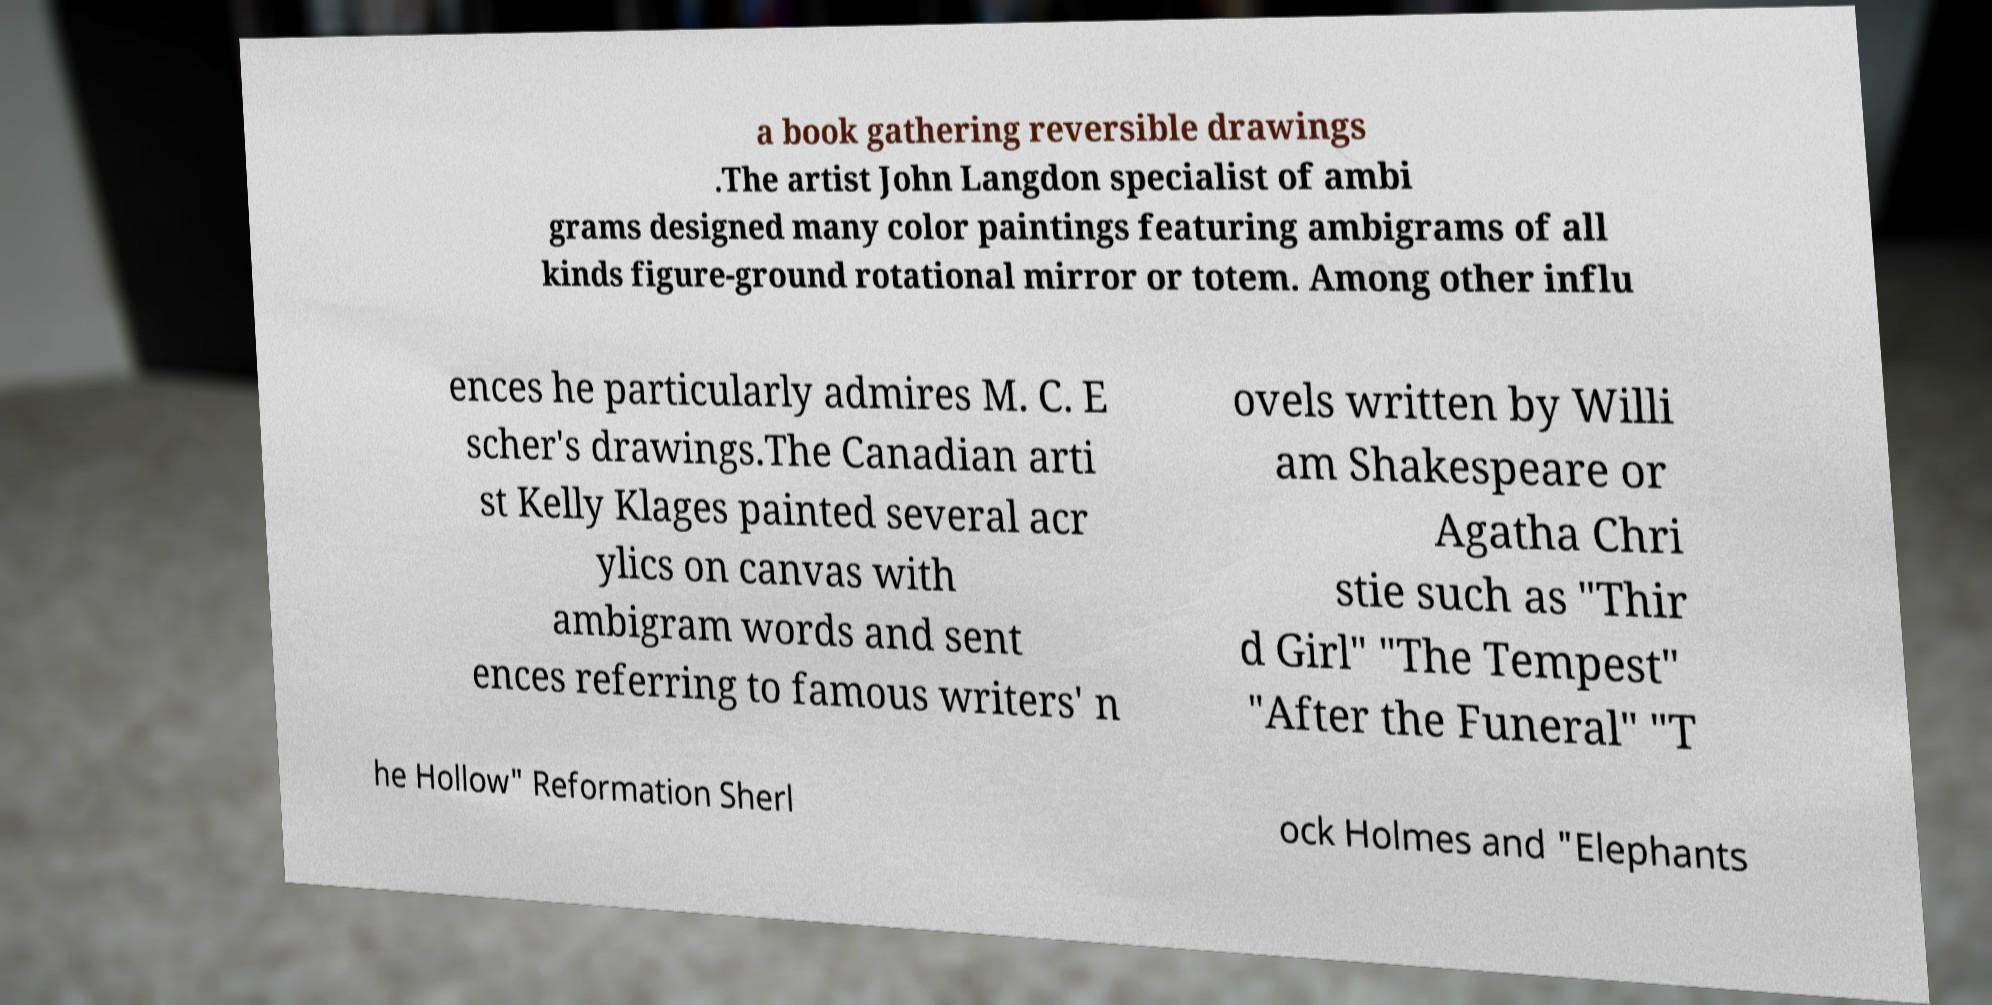Could you extract and type out the text from this image? a book gathering reversible drawings .The artist John Langdon specialist of ambi grams designed many color paintings featuring ambigrams of all kinds figure-ground rotational mirror or totem. Among other influ ences he particularly admires M. C. E scher's drawings.The Canadian arti st Kelly Klages painted several acr ylics on canvas with ambigram words and sent ences referring to famous writers' n ovels written by Willi am Shakespeare or Agatha Chri stie such as "Thir d Girl" "The Tempest" "After the Funeral" "T he Hollow" Reformation Sherl ock Holmes and "Elephants 